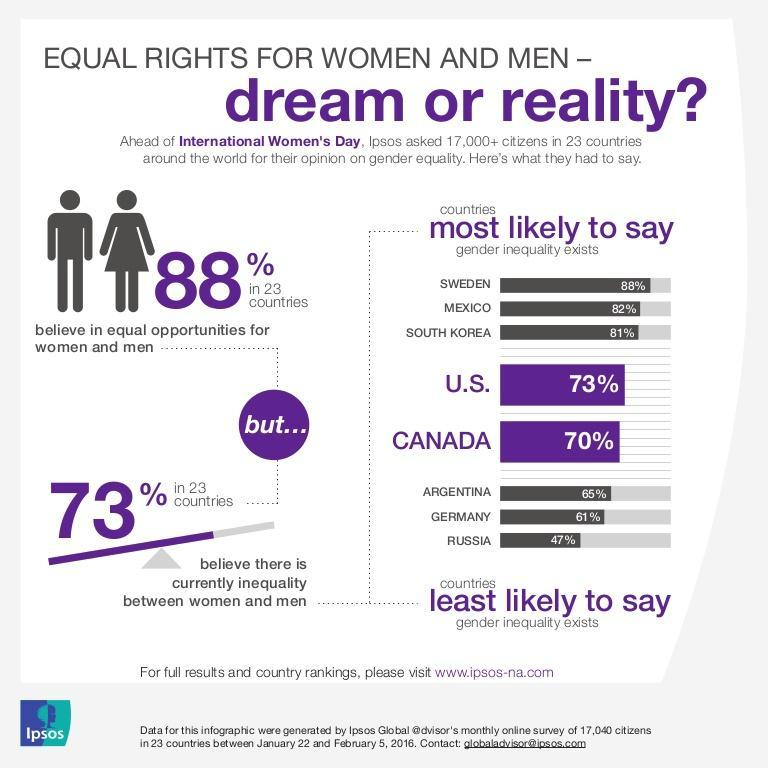Which countries have less than 20% respondents who think inequality does not exist?
Answer the question with a short phrase. Sweden, Mexico, South Korea Which country has respondents less than 50% who think inequality exists? Russia 